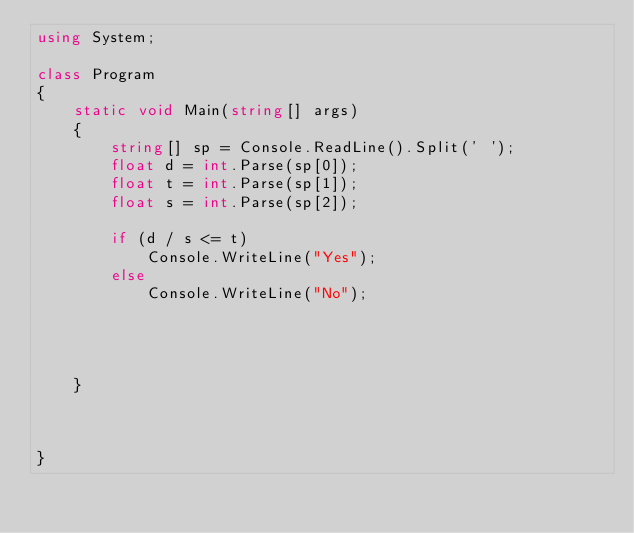<code> <loc_0><loc_0><loc_500><loc_500><_C#_>using System;

class Program
{
    static void Main(string[] args)
    {
        string[] sp = Console.ReadLine().Split(' ');
        float d = int.Parse(sp[0]);
        float t = int.Parse(sp[1]);
        float s = int.Parse(sp[2]);

        if (d / s <= t)
            Console.WriteLine("Yes");
        else
            Console.WriteLine("No");




    }



}


</code> 